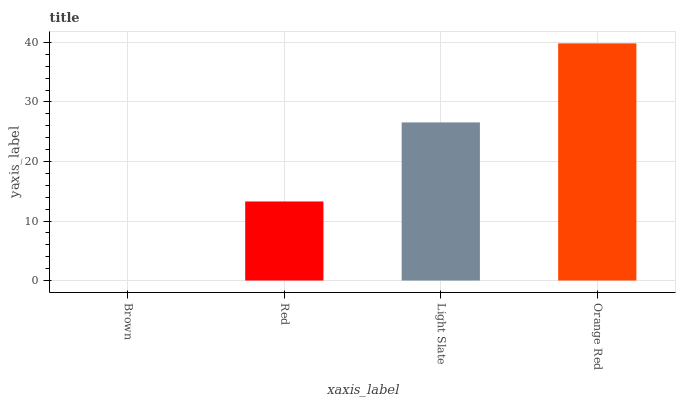Is Red the minimum?
Answer yes or no. No. Is Red the maximum?
Answer yes or no. No. Is Red greater than Brown?
Answer yes or no. Yes. Is Brown less than Red?
Answer yes or no. Yes. Is Brown greater than Red?
Answer yes or no. No. Is Red less than Brown?
Answer yes or no. No. Is Light Slate the high median?
Answer yes or no. Yes. Is Red the low median?
Answer yes or no. Yes. Is Orange Red the high median?
Answer yes or no. No. Is Brown the low median?
Answer yes or no. No. 